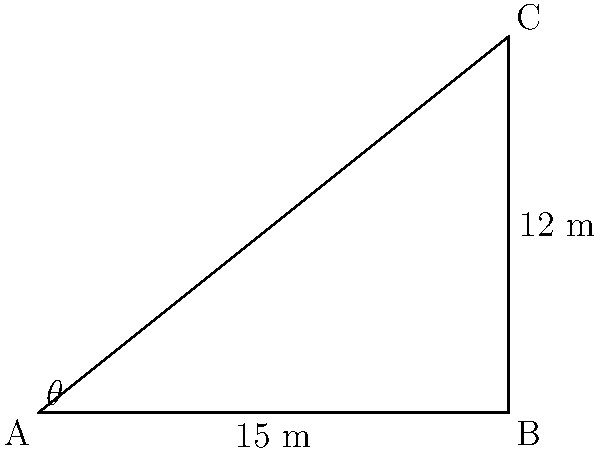A flagpole representing judicial independence is erected on level ground. The top of the flagpole is 12 meters high, and a support cable is attached from the top of the pole to a point on the ground 15 meters away from the base. Calculate the angle of inclination ($\theta$) of the flagpole with respect to the ground. To solve this problem, we'll use trigonometry, specifically the tangent function. Let's approach this step-by-step:

1) In the right triangle formed by the flagpole, ground, and support cable:
   - The adjacent side (ground distance) is 15 meters
   - The opposite side (flagpole height) is 12 meters
   - We need to find the angle $\theta$

2) The tangent of an angle in a right triangle is the ratio of the opposite side to the adjacent side:

   $$\tan \theta = \frac{\text{opposite}}{\text{adjacent}} = \frac{\text{height}}{\text{ground distance}}$$

3) Substituting our values:

   $$\tan \theta = \frac{12}{15}$$

4) To find $\theta$, we need to take the inverse tangent (arctan or $\tan^{-1}$) of both sides:

   $$\theta = \tan^{-1}\left(\frac{12}{15}\right)$$

5) Using a calculator or computer:

   $$\theta \approx 38.66^\circ$$

6) Rounding to two decimal places:

   $$\theta \approx 38.66^\circ$$

This angle represents the inclination of the flagpole with respect to the ground, symbolizing the upward trajectory of judicial independence in your political platform.
Answer: $38.66^\circ$ 